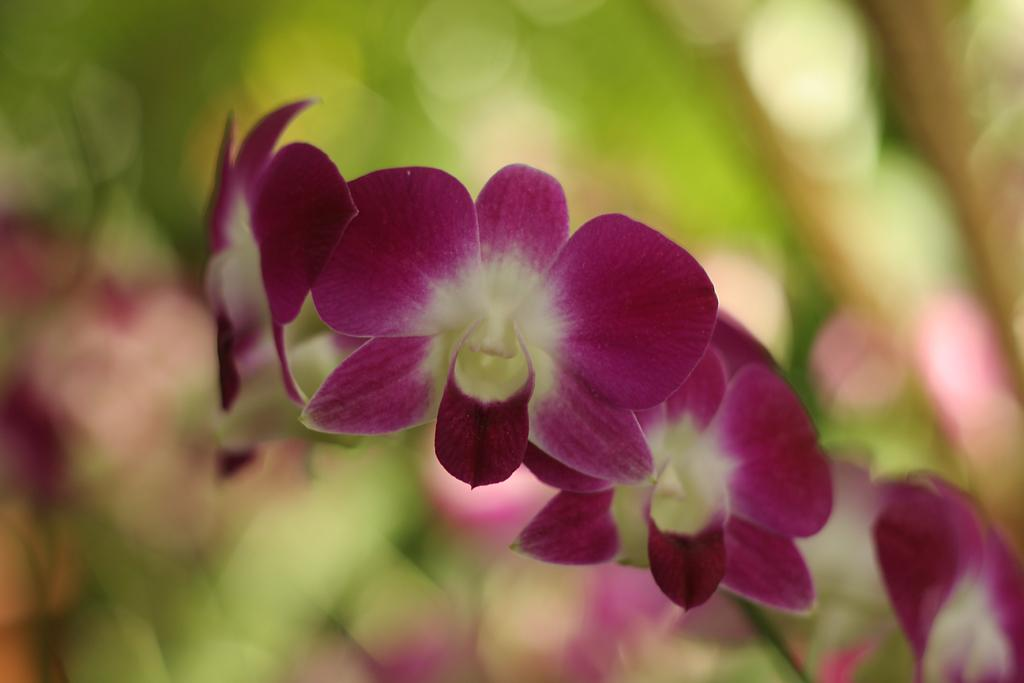What type of living organisms can be seen in the image? The image contains flowers. What is the primary subject of the image? The flowers are the main focus of the image. What type of paper can be seen in the image? There is no paper present in the image; it only contains flowers. How many dogs are visible in the image? There are no dogs present in the image; it only contains flowers. 